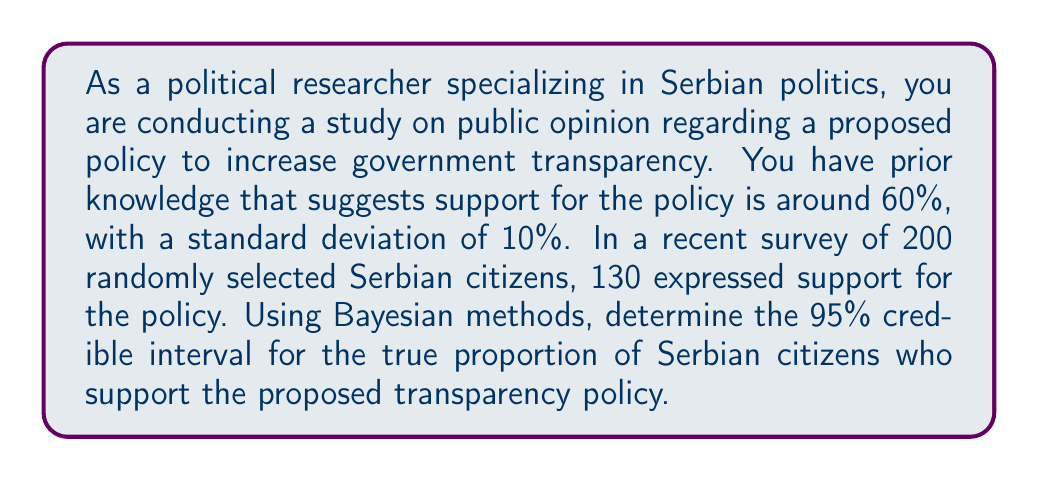Give your solution to this math problem. To solve this problem, we'll use Bayesian inference with a beta-binomial model. Let's break it down step-by-step:

1) First, we need to determine our prior distribution. Given the prior knowledge, we can use a beta distribution as our prior. We'll convert the mean (60%) and standard deviation (10%) to alpha and beta parameters:

   $\mu = \frac{\alpha}{\alpha + \beta} = 0.6$
   $\sigma^2 = \frac{\alpha\beta}{(\alpha + \beta)^2(\alpha + \beta + 1)} = 0.1^2 = 0.01$

   Solving these equations, we get:
   $\alpha \approx 13.2$ and $\beta \approx 8.8$

2) Our likelihood is binomial with n = 200 and x = 130.

3) The posterior distribution is also a beta distribution with parameters:
   $\alpha_{posterior} = \alpha_{prior} + x = 13.2 + 130 = 143.2$
   $\beta_{posterior} = \beta_{prior} + (n - x) = 8.8 + (200 - 130) = 78.8$

4) To find the 95% credible interval, we need to find the 2.5th and 97.5th percentiles of this beta distribution. We can use the inverse cumulative distribution function (quantile function) of the beta distribution:

   Lower bound: $qbeta(0.025, 143.2, 78.8)$
   Upper bound: $qbeta(0.975, 143.2, 78.8)$

5) Calculating these values (using a statistical software or calculator):
   Lower bound ≈ 0.5997
   Upper bound ≈ 0.6947

Therefore, the 95% credible interval is approximately (0.5997, 0.6947) or (59.97%, 69.47%).
Answer: The 95% credible interval for the true proportion of Serbian citizens who support the proposed transparency policy is approximately (59.97%, 69.47%). 